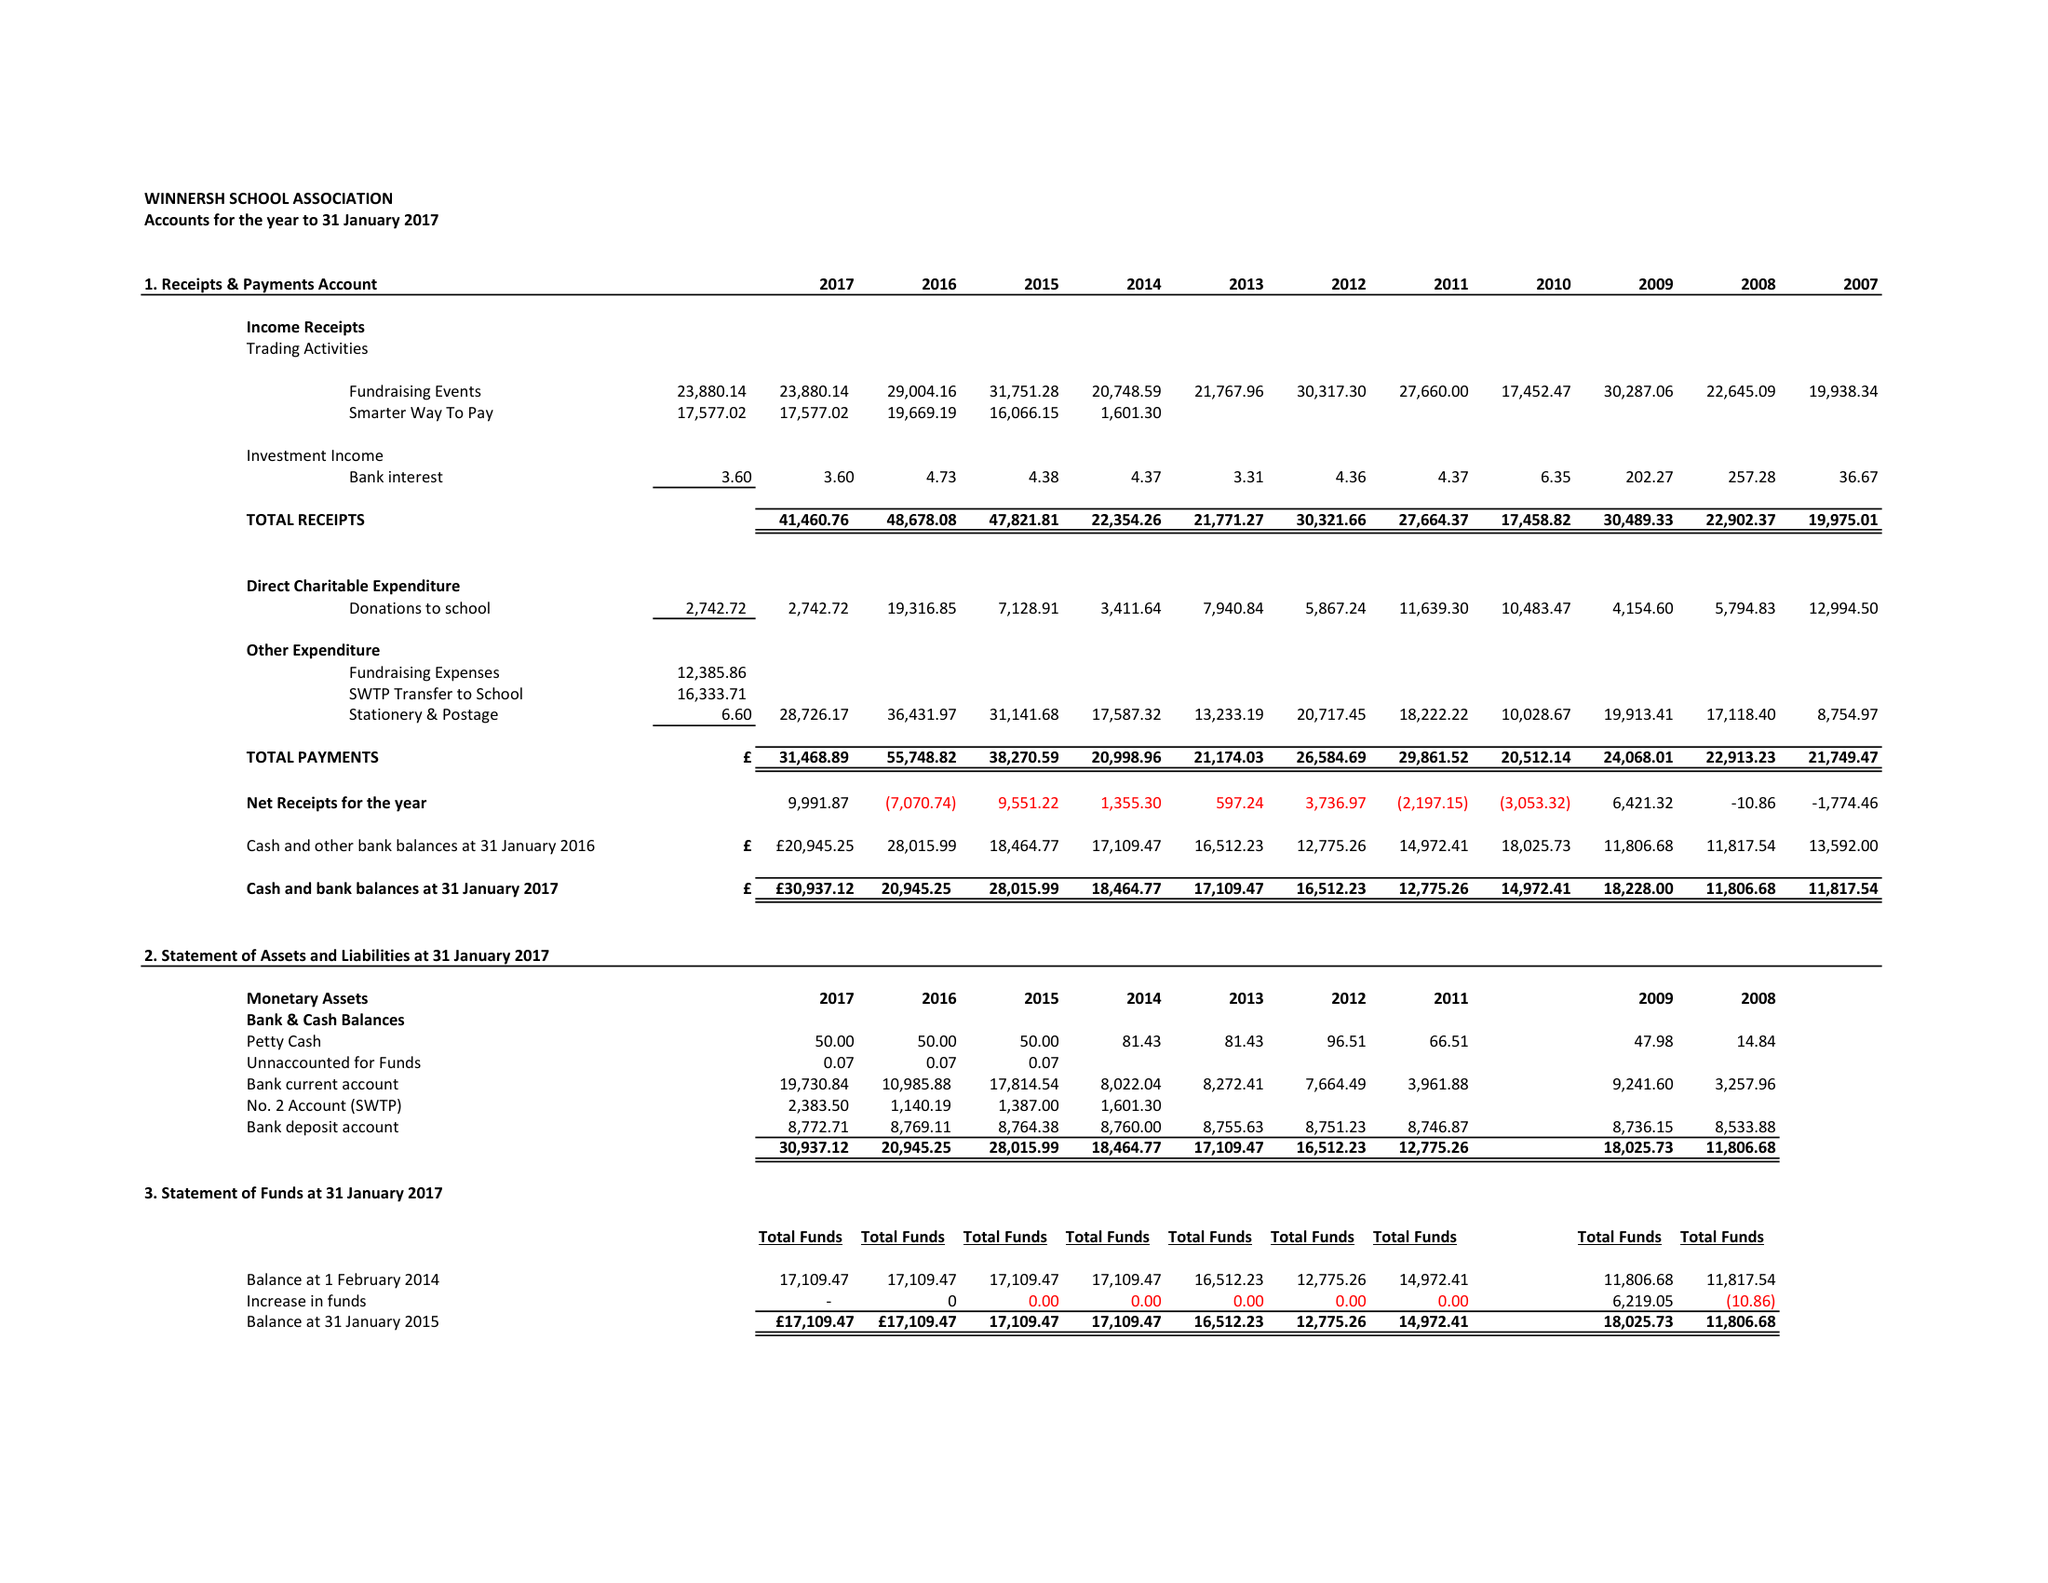What is the value for the report_date?
Answer the question using a single word or phrase. 2017-01-31 